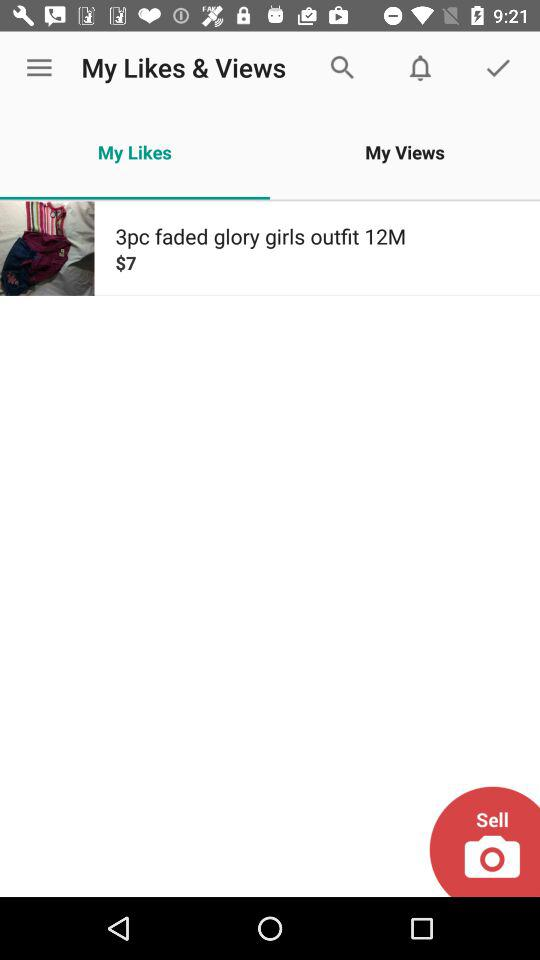Which tab is selected? The selected tab is "My Likes". 